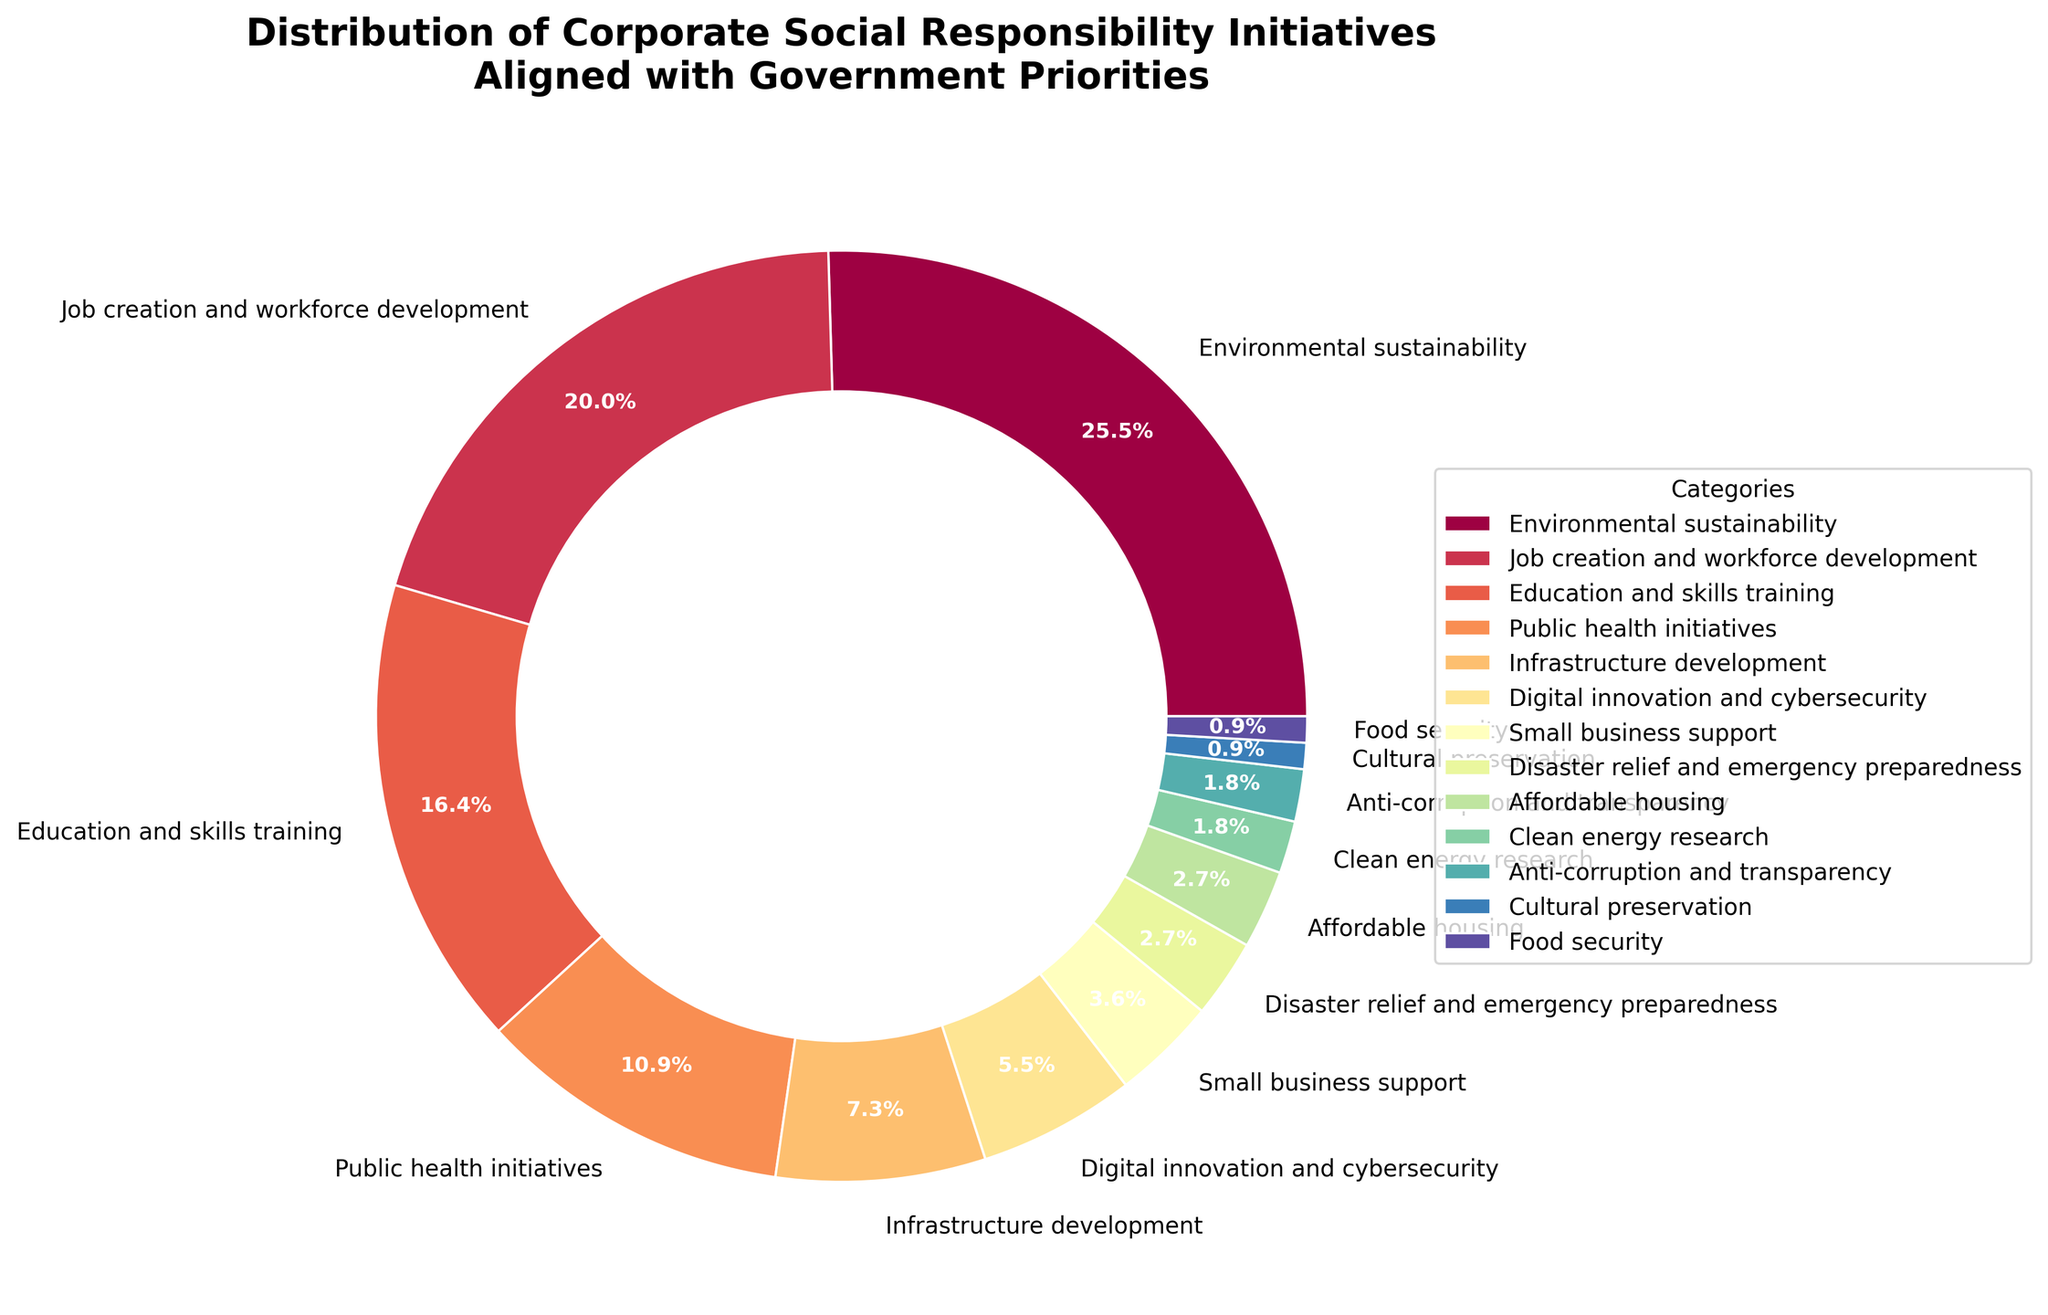What's the most common corporate social responsibility initiative aligned with government priorities? Identify the category with the largest percentage slice in the pie chart. The "Environmental sustainability" segment has the largest percentage.
Answer: Environmental sustainability Which two categories have the smallest percentage of initiatives? Locate the smallest slices in the pie chart. "Cultural preservation" and "Food security" both have the smallest slices sharing the same percentage.
Answer: Cultural preservation and Food security What is the combined percentage of initiatives related to public health and infrastructure development? Find the percentages for "Public health initiatives" and "Infrastructure development" from the chart and add them together: 12% + 8% = 20%.
Answer: 20% How does the percentage of job creation and workforce development compare with education and skills training? Compare the respective percentages from the pie chart: "Job creation and workforce development" (22%) and "Education and skills training" (18%).
Answer: Job creation and workforce development has a higher percentage What is the difference in percentage between digital innovation & cybersecurity and anti-corruption & transparency initiatives? Subtract the percentage of "Anti-corruption and transparency" (2%) from "Digital innovation & cybersecurity" (6%): 6% - 2% = 4%.
Answer: 4% How many categories have a percentage less than 5%? Identify categories with slices that represent less than 5% each: categories are "Small business support", "Disaster relief and emergency preparedness", "Affordable housing", "Clean energy research", "Anti-corruption and transparency", "Cultural preservation", and "Food security". Count them to get 7.
Answer: 7 What visual element is used to distinguish different categories in the chart? Notice the visual distinction techniques. Each category in the pie chart is represented by a different color.
Answer: Different colors What's the total percentage of initiatives related to environmental sustainability, public health, and job creation? Add the percentages for "Environmental sustainability", "Public health initiatives", and "Job creation and workforce development": 28% + 12% + 22% = 62%.
Answer: 62% Which category is represented by approximately one-quarter of the total percentage? Locate the slice(s) near 25% from the pie chart. The "Environmental sustainability" category has a percentage of 28%, which is approximately one-quarter of the total.
Answer: Environmental sustainability Is there a larger percentage of initiatives related to infrastructure development than to affordable housing? Compare the percentages of "Infrastructure development" (8%) and "Affordable housing" (3%). "Infrastructure development" has a larger percentage.
Answer: Yes 